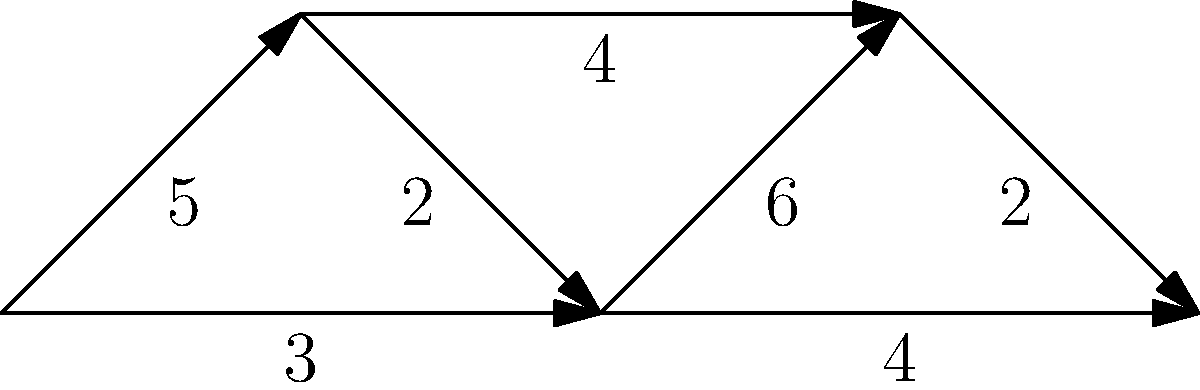Given the weighted graph representing data transfer routes between digital repositories, what is the shortest path from node A to node E, and what is its total weight? Consider the implications for maintaining data integrity during transfers. To find the shortest path from node A to node E, we'll use Dijkstra's algorithm, which is optimal for weighted graphs. Here's the step-by-step process:

1. Initialize:
   - Set distance to A as 0, all others as infinity.
   - Set all nodes as unvisited.
   - Set A as the current node.

2. For the current node, consider all unvisited neighbors and calculate their tentative distances:
   - A to B: 5
   - A to C: 3

3. Mark A as visited. Set C as the current node (smallest tentative distance).

4. From C:
   - C to B: 3 + 2 = 5 (no change for B)
   - C to D: 3 + 6 = 9
   - C to E: 3 + 4 = 7

5. Mark C as visited. Set B as the current node.

6. From B:
   - B to D: 5 + 4 = 9 (no change for D)

7. Mark B as visited. Set E as the current node.

8. From E:
   - E to D: 7 + 2 = 9 (no change for D)

9. Mark E as visited. Algorithm complete.

The shortest path is A → C → E, with a total weight of 7.

For data integrity, this path minimizes the number of intermediary nodes (reducing points of potential corruption) and total transfer time (reducing exposure to potential integrity threats).
Answer: A → C → E, total weight 7 